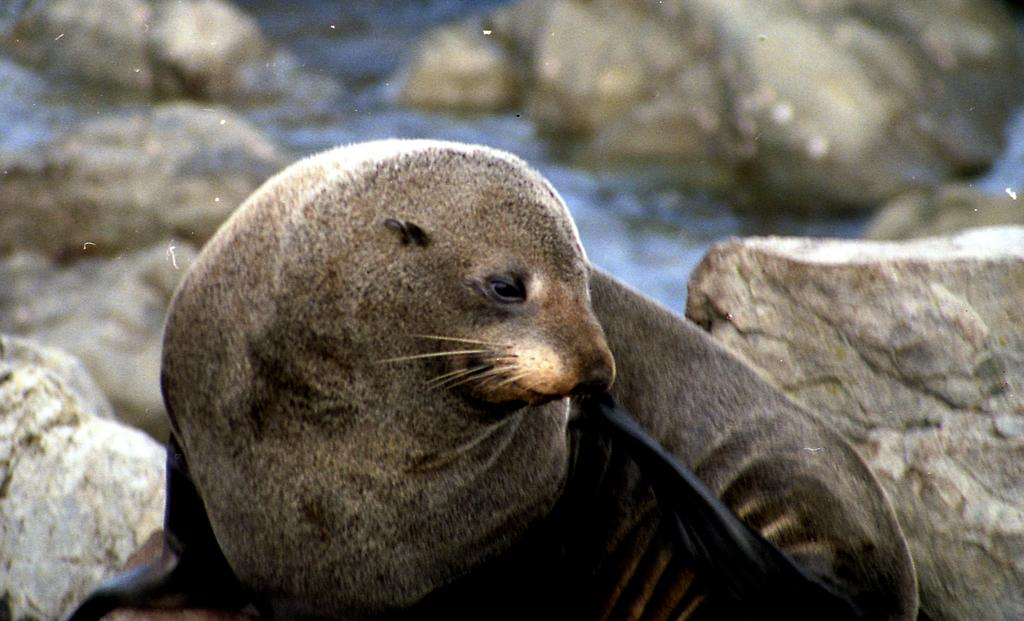What animal is in the foreground of the picture? There is a seal in the foreground of the picture. What can be seen in the background of the picture? There are stones and water visible in the background of the picture. What type of bubble can be seen floating near the seal in the image? There is no bubble present in the image; it features a seal in the foreground and stones and water in the background. 